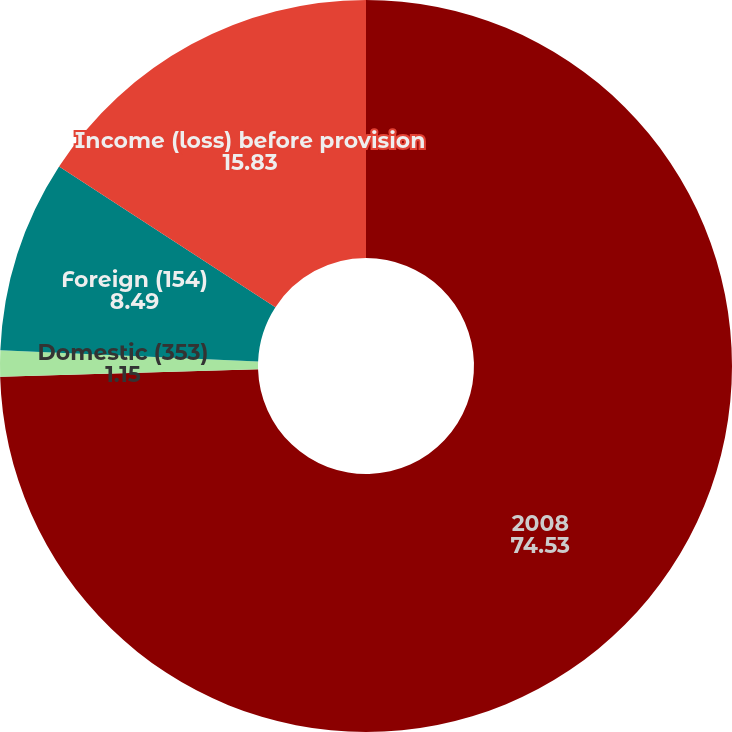Convert chart. <chart><loc_0><loc_0><loc_500><loc_500><pie_chart><fcel>2008<fcel>Domestic (353)<fcel>Foreign (154)<fcel>Income (loss) before provision<nl><fcel>74.53%<fcel>1.15%<fcel>8.49%<fcel>15.83%<nl></chart> 